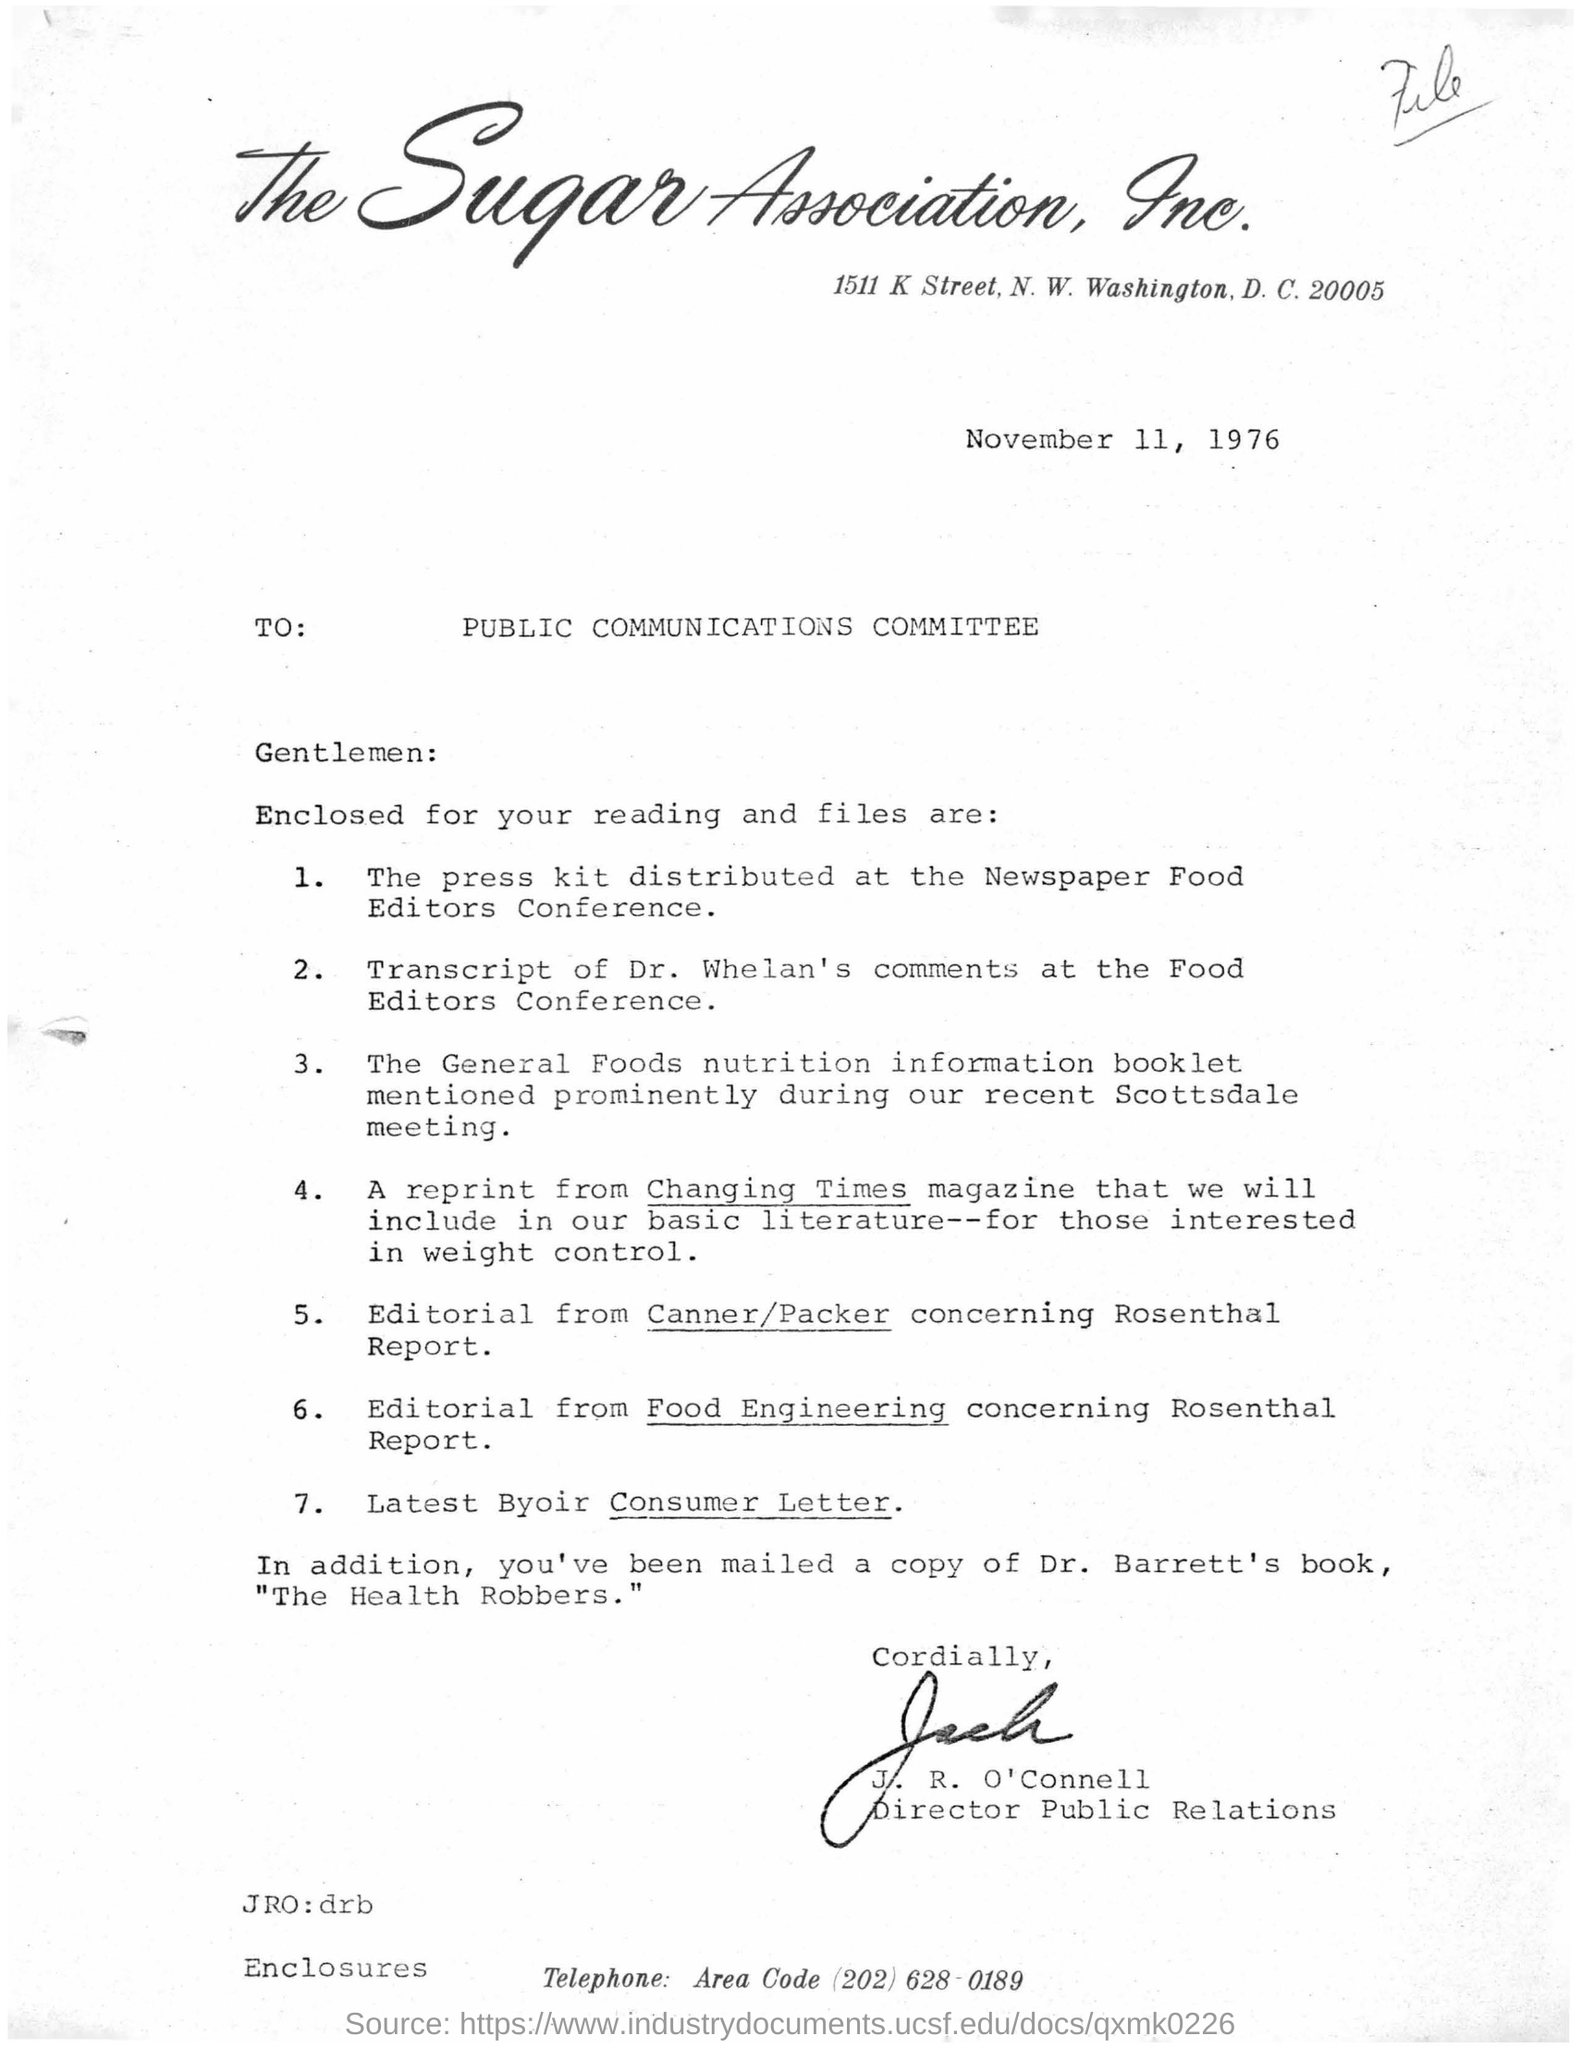What is the name of incorporated company?
Make the answer very short. The sugar association. What is the address of the sugar association,inc?
Provide a succinct answer. 1511 k street, N. W. Washington, D.C. 20005. When letter is dated on?
Provide a succinct answer. November 11, 1976. To which committee j.r. o'connell is sending this letter?
Your response must be concise. Public communications committee. What is the designation of  j.r. o'connell ?
Offer a very short reply. Director public relations. Whose comments at the food editors conference is enclosed??
Give a very brief answer. Dr. Whelan's. What is distributed at the newspaper food editors conference?
Offer a very short reply. The press kit. A reprint from which magazine would be included in the basic literature for those interested in weight control?
Your answer should be compact. Changing times. Who wrote the book  " the health robbers"?
Give a very brief answer. Dr. Barrett's. 